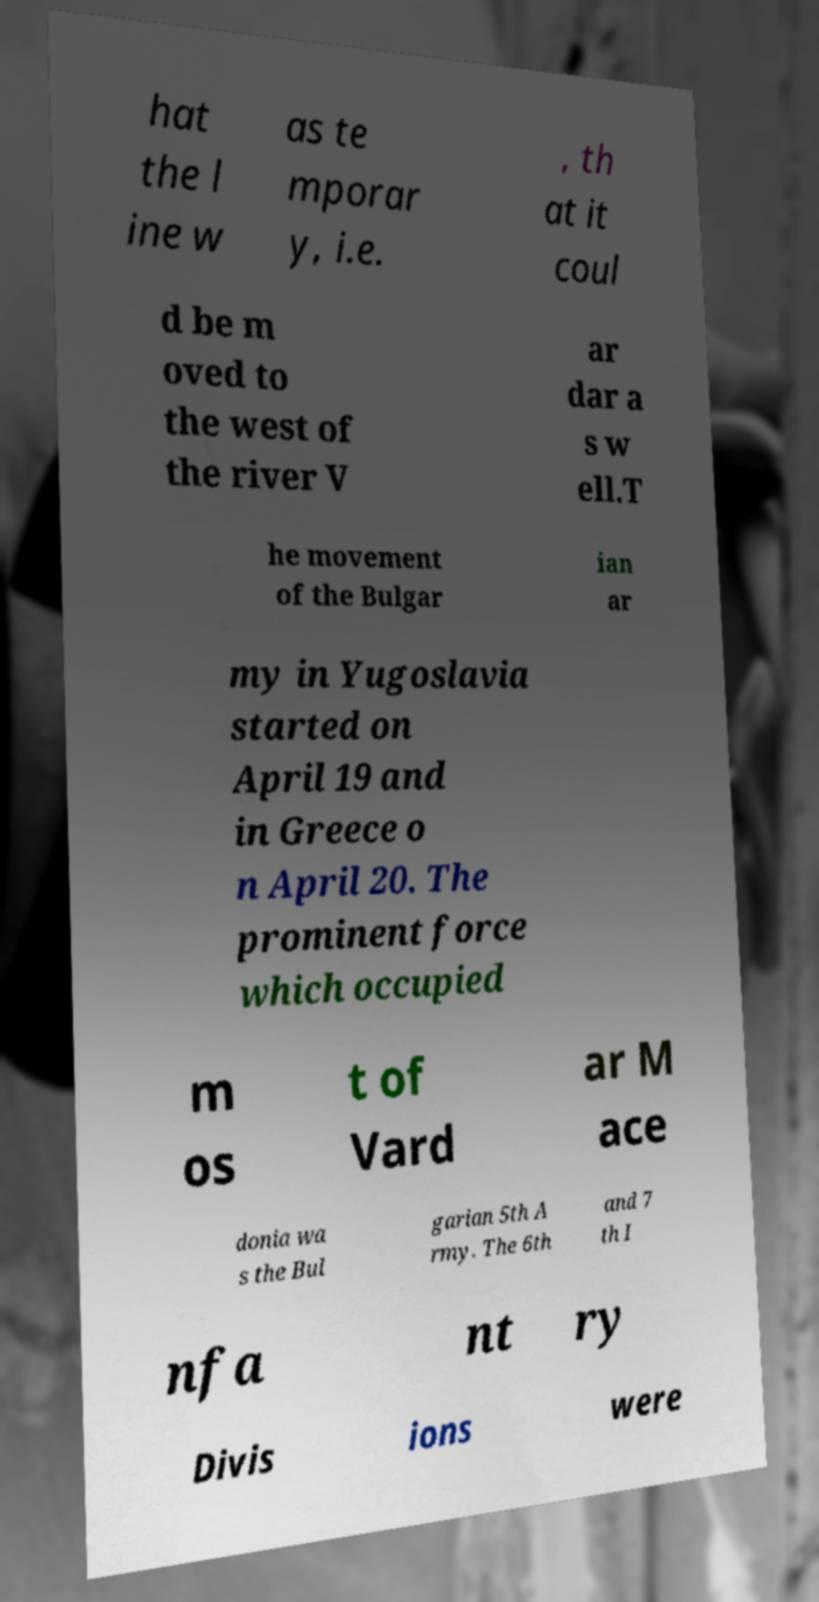For documentation purposes, I need the text within this image transcribed. Could you provide that? hat the l ine w as te mporar y, i.e. , th at it coul d be m oved to the west of the river V ar dar a s w ell.T he movement of the Bulgar ian ar my in Yugoslavia started on April 19 and in Greece o n April 20. The prominent force which occupied m os t of Vard ar M ace donia wa s the Bul garian 5th A rmy. The 6th and 7 th I nfa nt ry Divis ions were 